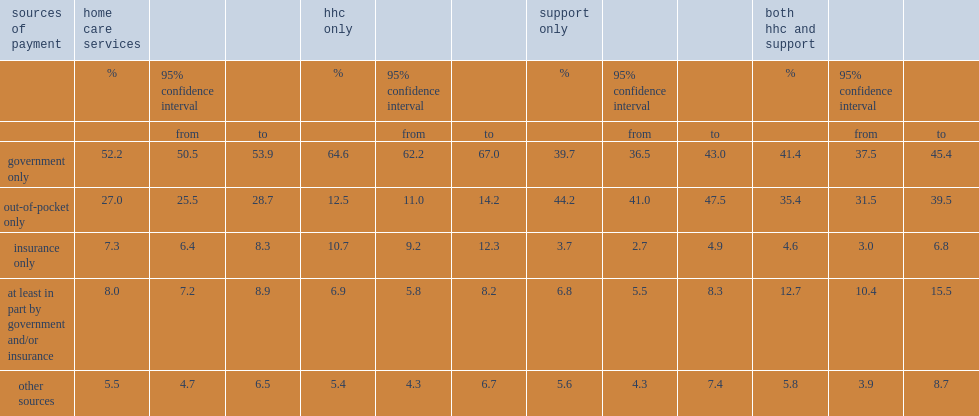What was the percentage of canadian households having home care service costs that were paid solely by government in 2015/2016? 52.2. Among canadian households receiving hhc services only, what did the proportion of those having home care service costs that were paid solely by government rise to in 2015/2016? 64.6. What was the percentage of canadian households paying solely out of pocket for home care services in 2015/2016? 27.0. What was the percentage of canadian households paying solely out of pocket for support services only in 2015/2016? 44.2. What was the percentage of canadian households paying solely out of pocket for hhc services only in 2015/2016? 12.5. What was the percentage of canadian households for which insurance covered home care service costs in 2015/2016? 7.3. What was the percentage of canadian households receiving home care services that were paid at least in part by government and/or insurance in 20115/2016? 8.0. What was the percentage of canadian households whose home care services were paid by other sources in 20115/2016? 5.5. Parse the table in full. {'header': ['sources of payment', 'home care services', '', '', 'hhc only', '', '', 'support only', '', '', 'both hhc and support', '', ''], 'rows': [['', '%', '95% confidence interval', '', '%', '95% confidence interval', '', '%', '95% confidence interval', '', '%', '95% confidence interval', ''], ['', '', 'from', 'to', '', 'from', 'to', '', 'from', 'to', '', 'from', 'to'], ['government only', '52.2', '50.5', '53.9', '64.6', '62.2', '67.0', '39.7', '36.5', '43.0', '41.4', '37.5', '45.4'], ['out-of-pocket only', '27.0', '25.5', '28.7', '12.5', '11.0', '14.2', '44.2', '41.0', '47.5', '35.4', '31.5', '39.5'], ['insurance only', '7.3', '6.4', '8.3', '10.7', '9.2', '12.3', '3.7', '2.7', '4.9', '4.6', '3.0', '6.8'], ['at least in part by government and/or insurance', '8.0', '7.2', '8.9', '6.9', '5.8', '8.2', '6.8', '5.5', '8.3', '12.7', '10.4', '15.5'], ['other sources', '5.5', '4.7', '6.5', '5.4', '4.3', '6.7', '5.6', '4.3', '7.4', '5.8', '3.9', '8.7']]} 